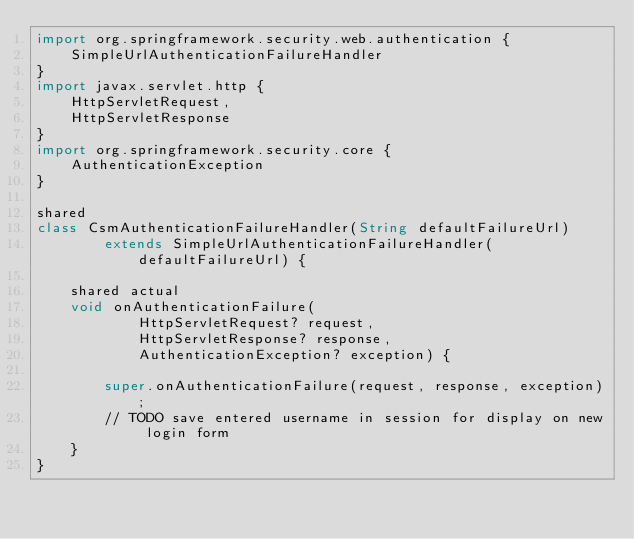Convert code to text. <code><loc_0><loc_0><loc_500><loc_500><_Ceylon_>import org.springframework.security.web.authentication {
    SimpleUrlAuthenticationFailureHandler
}
import javax.servlet.http {
    HttpServletRequest,
    HttpServletResponse
}
import org.springframework.security.core {
    AuthenticationException
}

shared
class CsmAuthenticationFailureHandler(String defaultFailureUrl)
        extends SimpleUrlAuthenticationFailureHandler(defaultFailureUrl) {

    shared actual
    void onAuthenticationFailure(
            HttpServletRequest? request,
            HttpServletResponse? response,
            AuthenticationException? exception) {

        super.onAuthenticationFailure(request, response, exception);
        // TODO save entered username in session for display on new login form
    }
}
</code> 